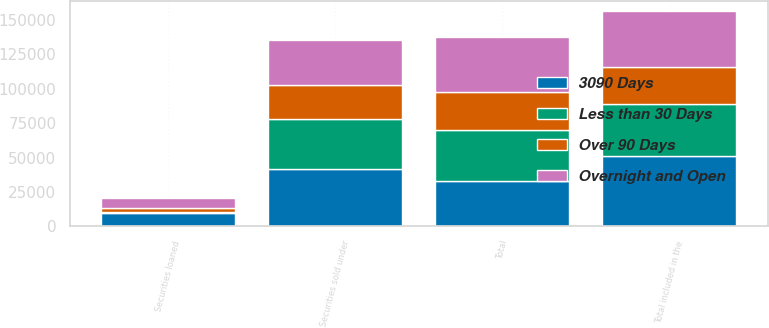Convert chart. <chart><loc_0><loc_0><loc_500><loc_500><stacked_bar_chart><ecel><fcel>Securities sold under<fcel>Securities loaned<fcel>Total included in the<fcel>Total<nl><fcel>3090 Days<fcel>41549<fcel>9487<fcel>51036<fcel>32661<nl><fcel>Less than 30 Days<fcel>36703<fcel>851<fcel>37554<fcel>37554<nl><fcel>Over 90 Days<fcel>24648<fcel>2863<fcel>27511<fcel>27511<nl><fcel>Overnight and Open<fcel>32661<fcel>7341<fcel>40002<fcel>40002<nl></chart> 